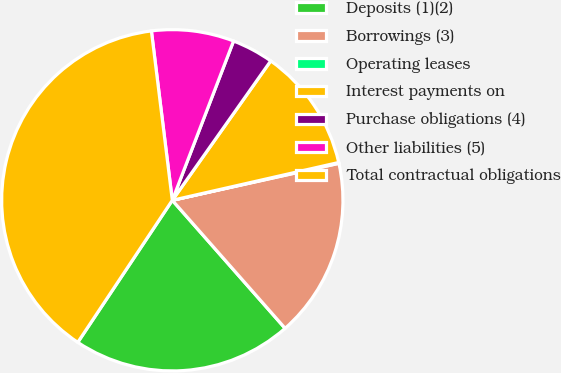Convert chart. <chart><loc_0><loc_0><loc_500><loc_500><pie_chart><fcel>Deposits (1)(2)<fcel>Borrowings (3)<fcel>Operating leases<fcel>Interest payments on<fcel>Purchase obligations (4)<fcel>Other liabilities (5)<fcel>Total contractual obligations<nl><fcel>20.84%<fcel>16.98%<fcel>0.08%<fcel>11.66%<fcel>3.94%<fcel>7.8%<fcel>38.7%<nl></chart> 